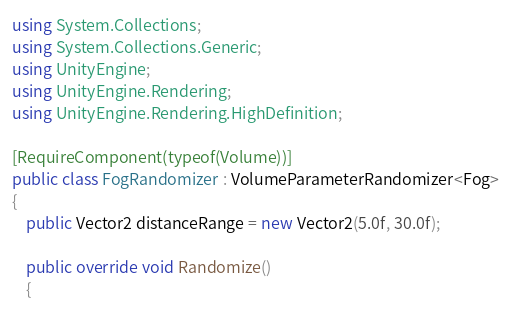<code> <loc_0><loc_0><loc_500><loc_500><_C#_>using System.Collections;
using System.Collections.Generic;
using UnityEngine;
using UnityEngine.Rendering;
using UnityEngine.Rendering.HighDefinition;

[RequireComponent(typeof(Volume))]
public class FogRandomizer : VolumeParameterRandomizer<Fog>
{
    public Vector2 distanceRange = new Vector2(5.0f, 30.0f);

    public override void Randomize()
    {</code> 